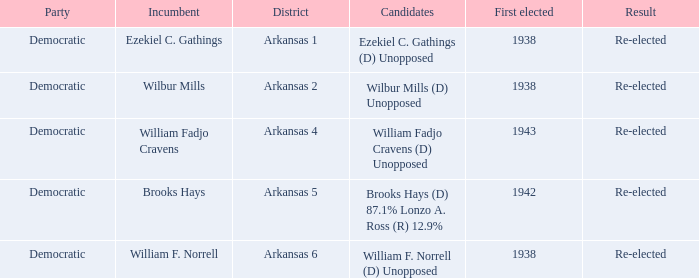To which party did the existing representative of the arkansas 6 district belong? Democratic. 